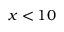<formula> <loc_0><loc_0><loc_500><loc_500>x < 1 0</formula> 